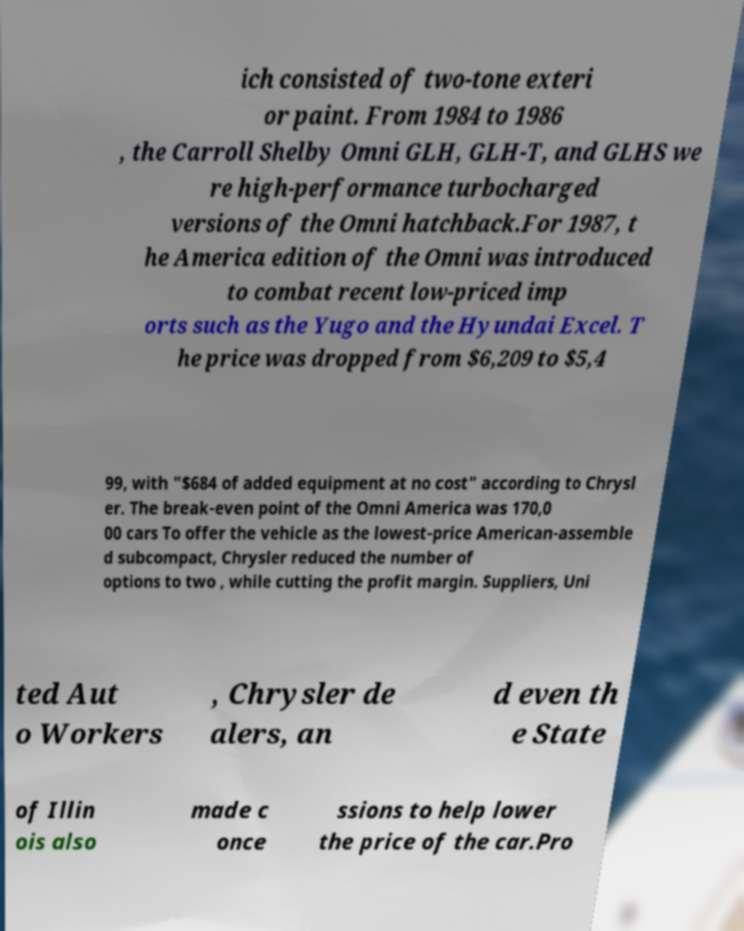Can you accurately transcribe the text from the provided image for me? ich consisted of two-tone exteri or paint. From 1984 to 1986 , the Carroll Shelby Omni GLH, GLH-T, and GLHS we re high-performance turbocharged versions of the Omni hatchback.For 1987, t he America edition of the Omni was introduced to combat recent low-priced imp orts such as the Yugo and the Hyundai Excel. T he price was dropped from $6,209 to $5,4 99, with "$684 of added equipment at no cost" according to Chrysl er. The break-even point of the Omni America was 170,0 00 cars To offer the vehicle as the lowest-price American-assemble d subcompact, Chrysler reduced the number of options to two , while cutting the profit margin. Suppliers, Uni ted Aut o Workers , Chrysler de alers, an d even th e State of Illin ois also made c once ssions to help lower the price of the car.Pro 